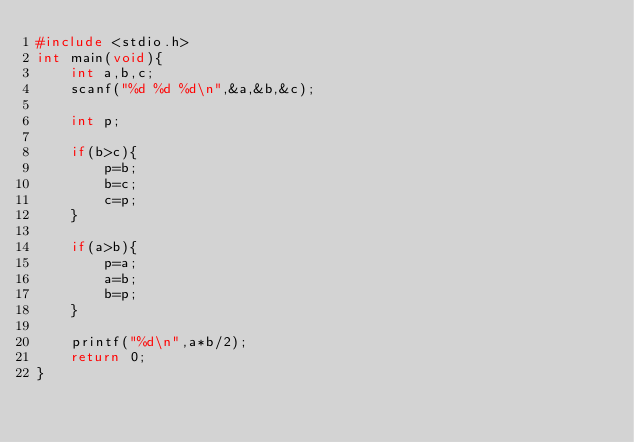Convert code to text. <code><loc_0><loc_0><loc_500><loc_500><_C_>#include <stdio.h>
int main(void){
    int a,b,c;
    scanf("%d %d %d\n",&a,&b,&c);
    
    int p;
    
    if(b>c){
        p=b;
        b=c;
        c=p;
    }
    
    if(a>b){
        p=a;
        a=b;
        b=p;
    }
    
    printf("%d\n",a*b/2);
    return 0;
}</code> 